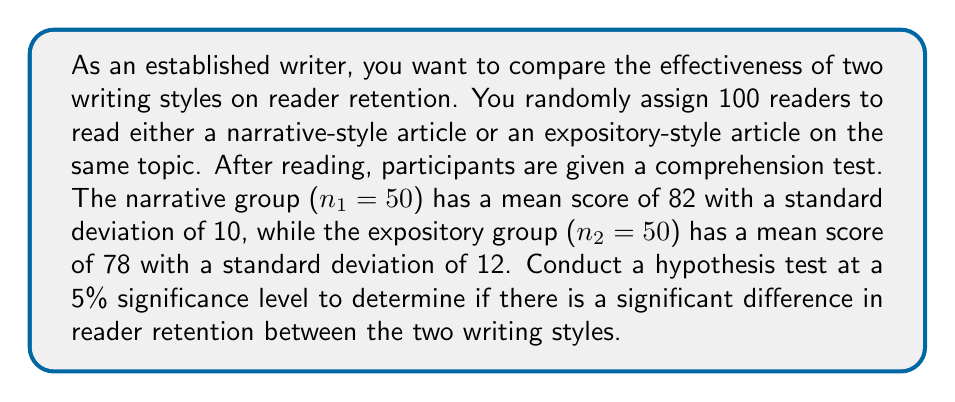Show me your answer to this math problem. 1. State the hypotheses:
   $H_0: \mu_1 - \mu_2 = 0$ (no difference in mean scores)
   $H_a: \mu_1 - \mu_2 \neq 0$ (there is a difference in mean scores)

2. Choose the significance level: $\alpha = 0.05$

3. Calculate the pooled standard error:
   $$SE = \sqrt{\frac{s_1^2}{n_1} + \frac{s_2^2}{n_2}} = \sqrt{\frac{10^2}{50} + \frac{12^2}{50}} = 2.2$

4. Calculate the t-statistic:
   $$t = \frac{(\bar{x}_1 - \bar{x}_2) - (\mu_1 - \mu_2)}{SE} = \frac{(82 - 78) - 0}{2.2} = 1.82$$

5. Determine the critical values for a two-tailed test with $df = n_1 + n_2 - 2 = 98$:
   $t_{critical} = \pm 1.984$ (from t-distribution table)

6. Compare the t-statistic to the critical values:
   $-1.984 < 1.82 < 1.984$

7. Calculate the p-value:
   $p-value = 2 \times P(T > |1.82|) \approx 0.0719$

8. Make a decision:
   Since $p-value > \alpha$ (0.0719 > 0.05), we fail to reject the null hypothesis.
Answer: Fail to reject $H_0$. Insufficient evidence to conclude a significant difference in reader retention between narrative and expository writing styles at $\alpha = 0.05$. 